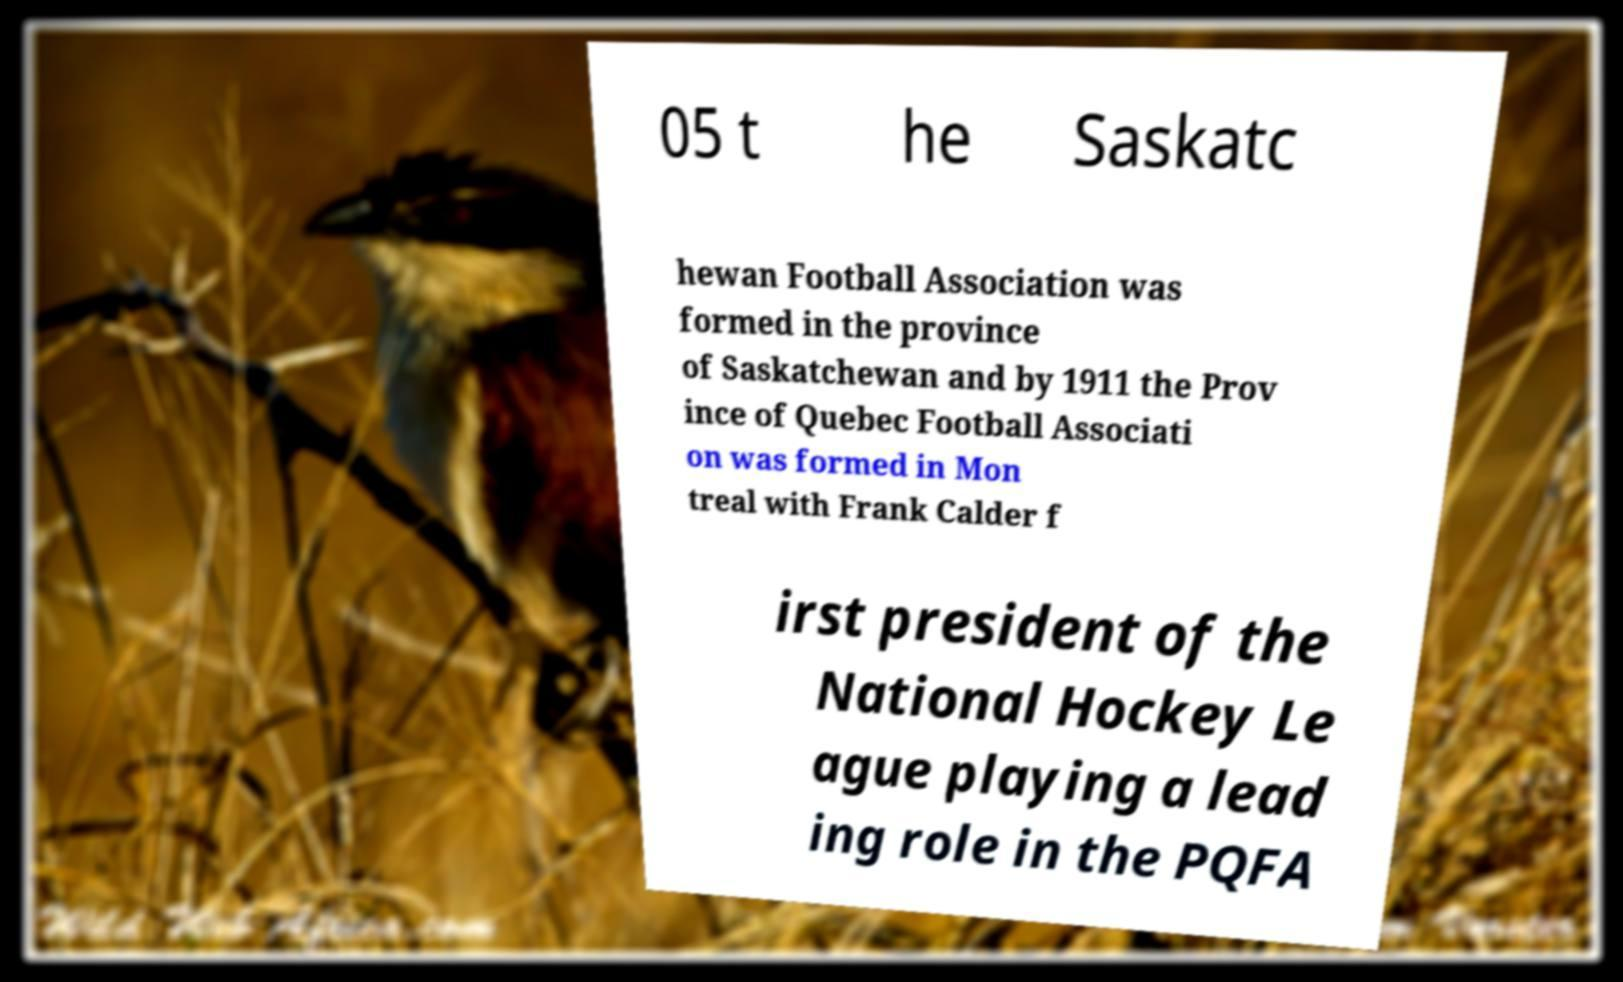Please read and relay the text visible in this image. What does it say? 05 t he Saskatc hewan Football Association was formed in the province of Saskatchewan and by 1911 the Prov ince of Quebec Football Associati on was formed in Mon treal with Frank Calder f irst president of the National Hockey Le ague playing a lead ing role in the PQFA 